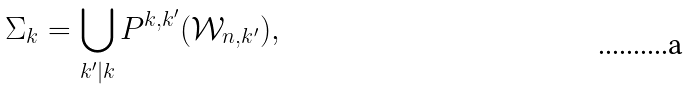<formula> <loc_0><loc_0><loc_500><loc_500>\Sigma _ { k } = \bigcup _ { k ^ { \prime } | k } P ^ { k , k ^ { \prime } } ( { \mathcal { W } } _ { n , k ^ { \prime } } ) ,</formula> 